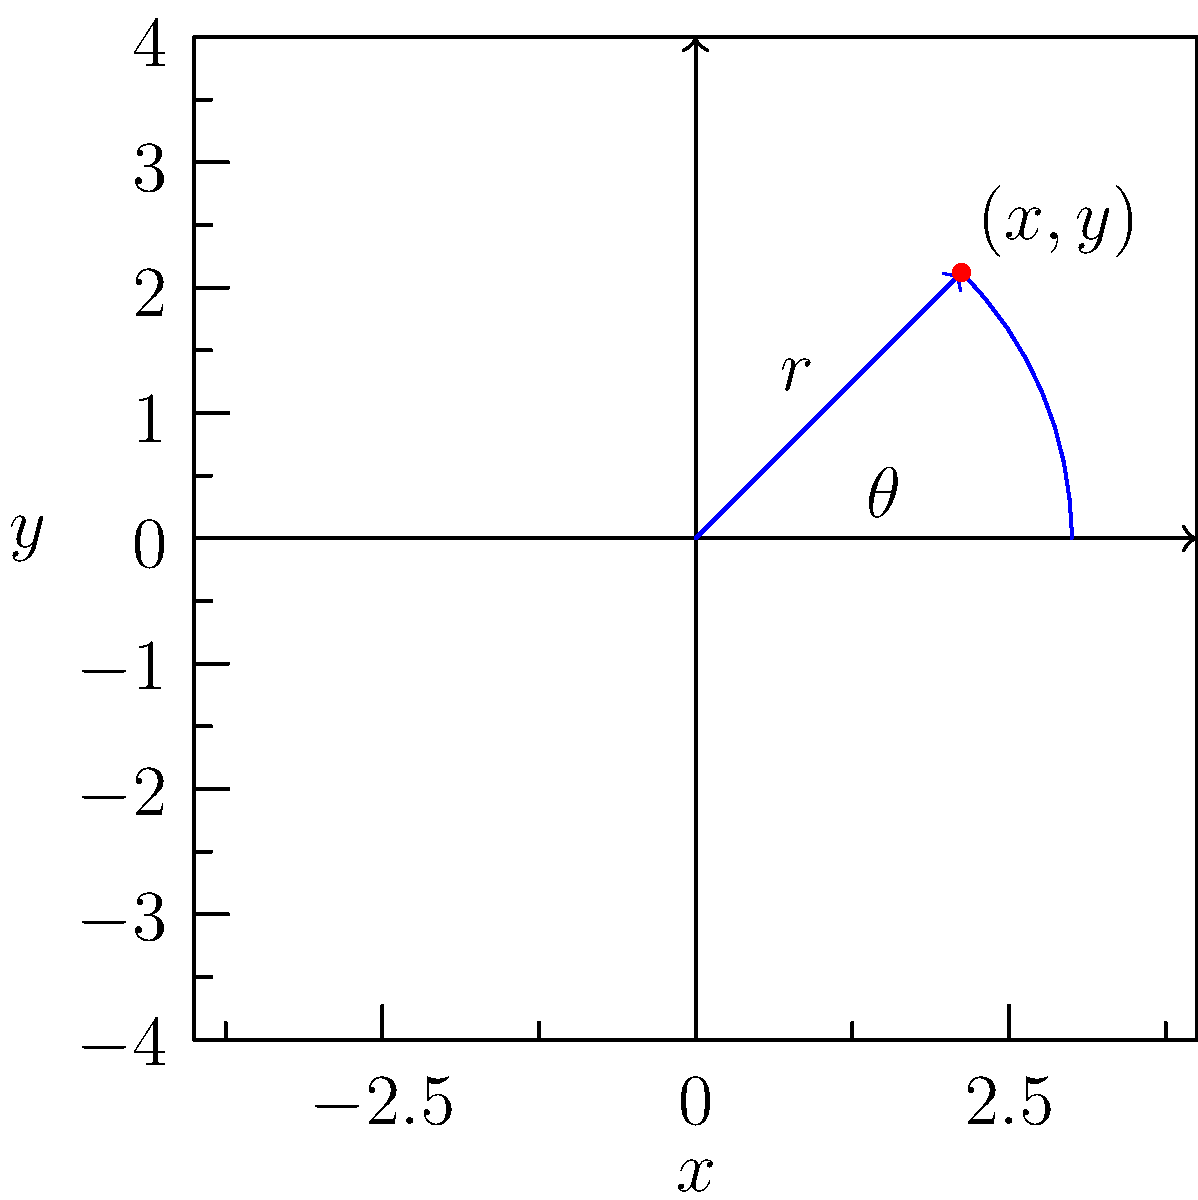Given a point in polar coordinates $(r,\theta)=(3,\frac{\pi}{4})$, determine its Cartesian coordinates $(x,y)$. Express your answer in terms of $\sqrt{2}$. To convert from polar coordinates $(r,\theta)$ to Cartesian coordinates $(x,y)$, we use the following formulas:

1) $x = r \cos(\theta)$
2) $y = r \sin(\theta)$

Given: $r = 3$ and $\theta = \frac{\pi}{4}$

Step 1: Calculate $x$
$x = r \cos(\theta) = 3 \cos(\frac{\pi}{4})$
$\cos(\frac{\pi}{4}) = \frac{\sqrt{2}}{2}$
Thus, $x = 3 \cdot \frac{\sqrt{2}}{2} = \frac{3\sqrt{2}}{2}$

Step 2: Calculate $y$
$y = r \sin(\theta) = 3 \sin(\frac{\pi}{4})$
$\sin(\frac{\pi}{4}) = \frac{\sqrt{2}}{2}$
Thus, $y = 3 \cdot \frac{\sqrt{2}}{2} = \frac{3\sqrt{2}}{2}$

Therefore, the Cartesian coordinates are $(\frac{3\sqrt{2}}{2}, \frac{3\sqrt{2}}{2})$.
Answer: $(\frac{3\sqrt{2}}{2}, \frac{3\sqrt{2}}{2})$ 